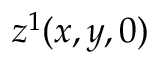Convert formula to latex. <formula><loc_0><loc_0><loc_500><loc_500>z ^ { 1 } ( x , y , 0 )</formula> 